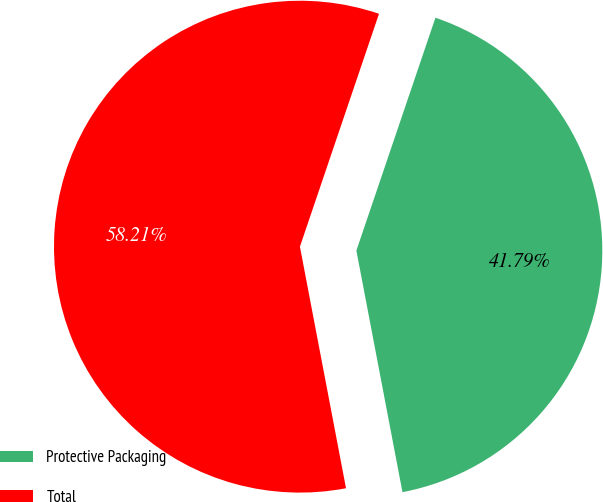<chart> <loc_0><loc_0><loc_500><loc_500><pie_chart><fcel>Protective Packaging<fcel>Total<nl><fcel>41.79%<fcel>58.21%<nl></chart> 